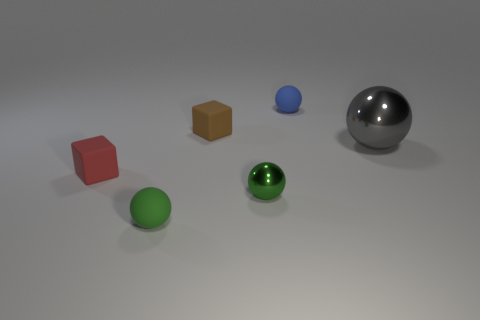Is there any other thing that is the same size as the gray thing?
Offer a very short reply. No. What material is the thing that is both behind the big object and in front of the blue ball?
Offer a terse response. Rubber. Do the object on the right side of the small blue rubber object and the brown matte thing that is left of the gray metal ball have the same shape?
Give a very brief answer. No. What shape is the matte thing that is the same color as the tiny shiny thing?
Keep it short and to the point. Sphere. What number of objects are either metal spheres that are to the right of the blue ball or tiny green shiny spheres?
Your answer should be compact. 2. Does the blue ball have the same size as the gray shiny thing?
Provide a succinct answer. No. There is a sphere that is on the left side of the tiny green metallic thing; what is its color?
Offer a terse response. Green. There is a thing that is the same material as the large sphere; what is its size?
Offer a very short reply. Small. There is a green rubber thing; is it the same size as the matte cube that is behind the small red block?
Ensure brevity in your answer.  Yes. There is a green object right of the small brown cube; what material is it?
Give a very brief answer. Metal. 